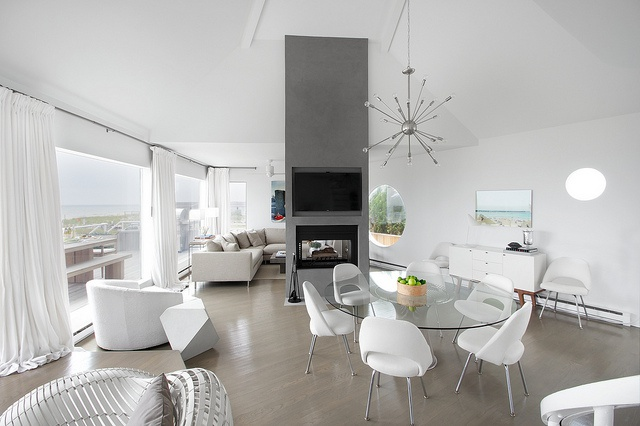Describe the objects in this image and their specific colors. I can see chair in darkgray, lightgray, and gray tones, dining table in darkgray, lightgray, and gray tones, chair in darkgray, lightgray, and gray tones, chair in darkgray, lightgray, and gray tones, and couch in darkgray, lightgray, and gray tones in this image. 